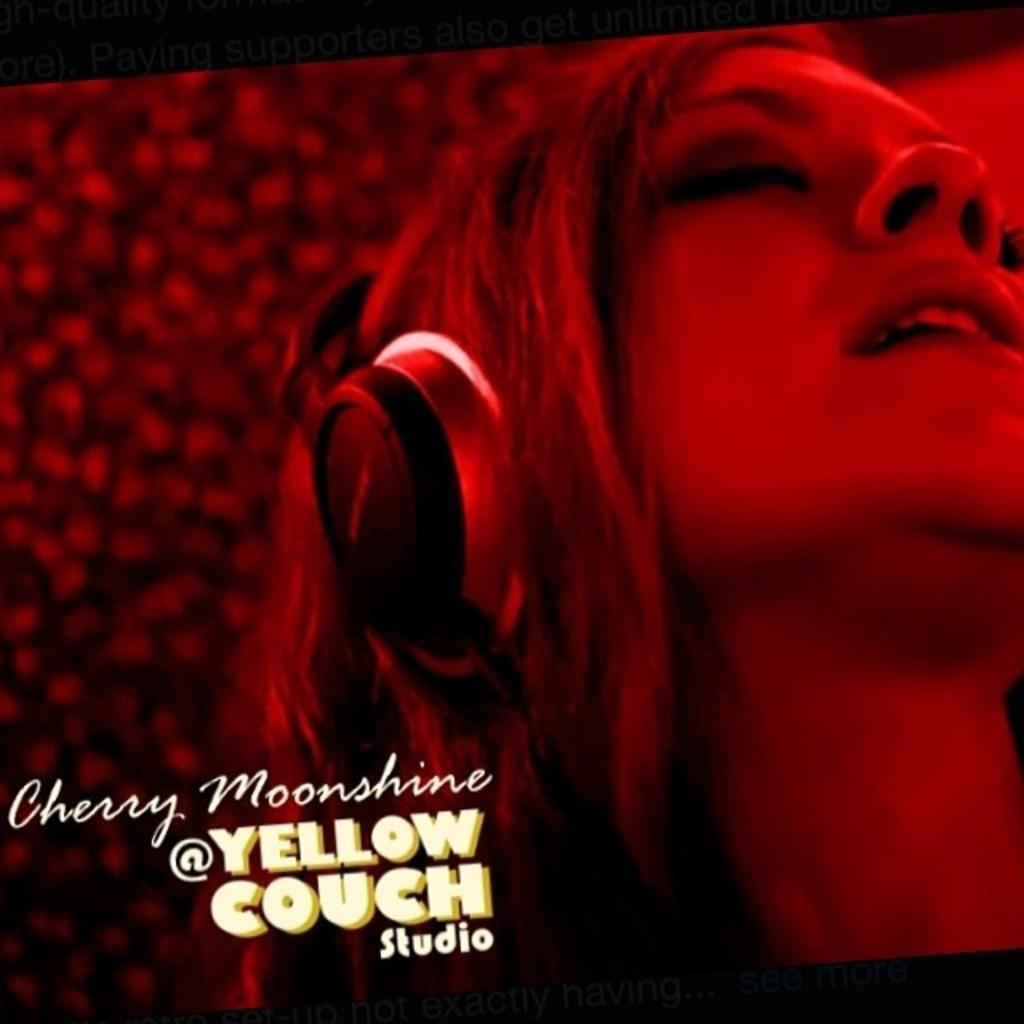In one or two sentences, can you explain what this image depicts? This image consists of a poster in which there is a woman wearing headsets. At the bottom, there is a text. The background is red in color. 